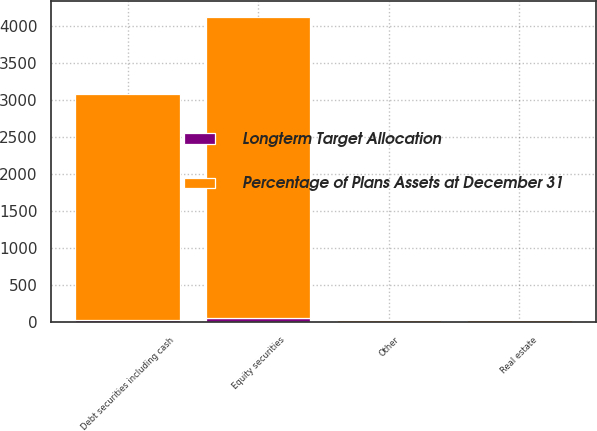Convert chart. <chart><loc_0><loc_0><loc_500><loc_500><stacked_bar_chart><ecel><fcel>Equity securities<fcel>Debt securities including cash<fcel>Real estate<fcel>Other<nl><fcel>Longterm Target Allocation<fcel>61<fcel>33<fcel>4<fcel>2<nl><fcel>Percentage of Plans Assets at December 31<fcel>4065<fcel>3045<fcel>28<fcel>26<nl></chart> 